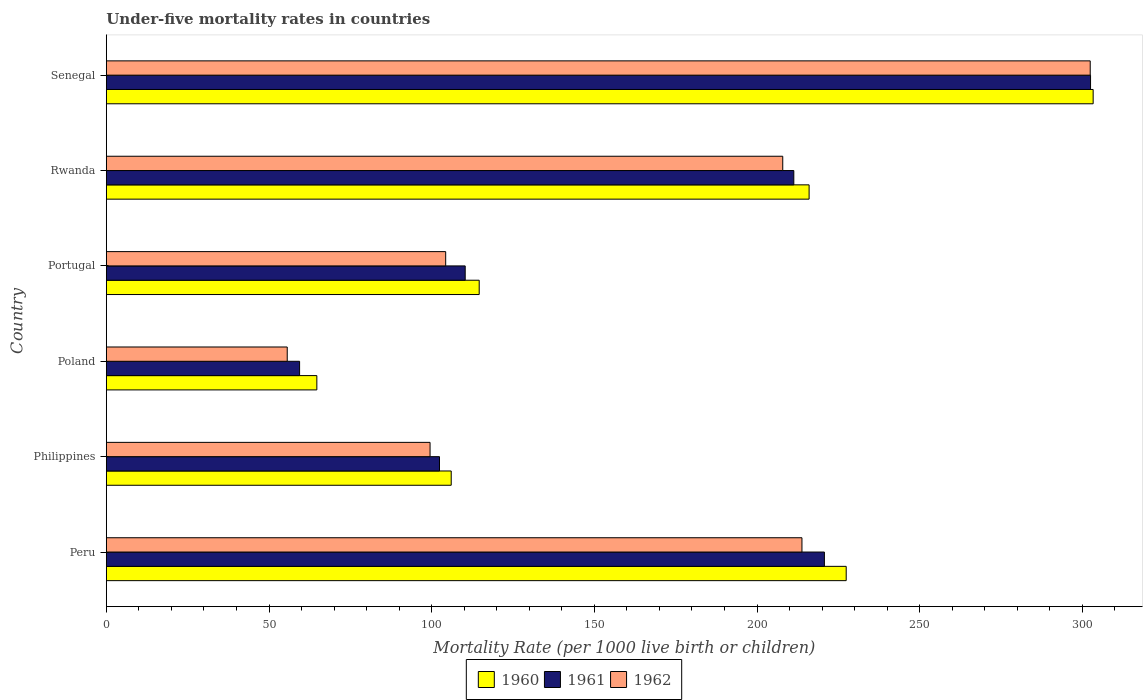How many groups of bars are there?
Offer a very short reply. 6. How many bars are there on the 4th tick from the bottom?
Offer a very short reply. 3. What is the label of the 1st group of bars from the top?
Offer a very short reply. Senegal. In how many cases, is the number of bars for a given country not equal to the number of legend labels?
Provide a succinct answer. 0. What is the under-five mortality rate in 1960 in Portugal?
Provide a short and direct response. 114.6. Across all countries, what is the maximum under-five mortality rate in 1960?
Your answer should be compact. 303.3. Across all countries, what is the minimum under-five mortality rate in 1960?
Offer a terse response. 64.7. In which country was the under-five mortality rate in 1962 maximum?
Ensure brevity in your answer.  Senegal. In which country was the under-five mortality rate in 1960 minimum?
Keep it short and to the point. Poland. What is the total under-five mortality rate in 1960 in the graph?
Offer a very short reply. 1032. What is the difference between the under-five mortality rate in 1961 in Rwanda and that in Senegal?
Offer a terse response. -91.2. What is the difference between the under-five mortality rate in 1961 in Poland and the under-five mortality rate in 1960 in Senegal?
Offer a terse response. -243.9. What is the average under-five mortality rate in 1960 per country?
Your answer should be very brief. 172. What is the difference between the under-five mortality rate in 1962 and under-five mortality rate in 1960 in Rwanda?
Your response must be concise. -8.1. What is the ratio of the under-five mortality rate in 1962 in Philippines to that in Portugal?
Provide a short and direct response. 0.95. Is the difference between the under-five mortality rate in 1962 in Peru and Poland greater than the difference between the under-five mortality rate in 1960 in Peru and Poland?
Keep it short and to the point. No. What is the difference between the highest and the second highest under-five mortality rate in 1960?
Your answer should be very brief. 75.9. What is the difference between the highest and the lowest under-five mortality rate in 1961?
Offer a very short reply. 243.1. Is the sum of the under-five mortality rate in 1960 in Philippines and Rwanda greater than the maximum under-five mortality rate in 1962 across all countries?
Offer a terse response. Yes. What does the 3rd bar from the bottom in Senegal represents?
Ensure brevity in your answer.  1962. How many bars are there?
Your response must be concise. 18. How many countries are there in the graph?
Make the answer very short. 6. How many legend labels are there?
Offer a terse response. 3. How are the legend labels stacked?
Ensure brevity in your answer.  Horizontal. What is the title of the graph?
Provide a short and direct response. Under-five mortality rates in countries. What is the label or title of the X-axis?
Keep it short and to the point. Mortality Rate (per 1000 live birth or children). What is the Mortality Rate (per 1000 live birth or children) in 1960 in Peru?
Ensure brevity in your answer.  227.4. What is the Mortality Rate (per 1000 live birth or children) in 1961 in Peru?
Keep it short and to the point. 220.7. What is the Mortality Rate (per 1000 live birth or children) of 1962 in Peru?
Offer a very short reply. 213.8. What is the Mortality Rate (per 1000 live birth or children) of 1960 in Philippines?
Your response must be concise. 106. What is the Mortality Rate (per 1000 live birth or children) in 1961 in Philippines?
Your answer should be very brief. 102.4. What is the Mortality Rate (per 1000 live birth or children) in 1962 in Philippines?
Make the answer very short. 99.5. What is the Mortality Rate (per 1000 live birth or children) of 1960 in Poland?
Provide a succinct answer. 64.7. What is the Mortality Rate (per 1000 live birth or children) in 1961 in Poland?
Your response must be concise. 59.4. What is the Mortality Rate (per 1000 live birth or children) in 1962 in Poland?
Your answer should be compact. 55.6. What is the Mortality Rate (per 1000 live birth or children) in 1960 in Portugal?
Give a very brief answer. 114.6. What is the Mortality Rate (per 1000 live birth or children) of 1961 in Portugal?
Your response must be concise. 110.3. What is the Mortality Rate (per 1000 live birth or children) of 1962 in Portugal?
Provide a short and direct response. 104.3. What is the Mortality Rate (per 1000 live birth or children) in 1960 in Rwanda?
Your response must be concise. 216. What is the Mortality Rate (per 1000 live birth or children) in 1961 in Rwanda?
Give a very brief answer. 211.3. What is the Mortality Rate (per 1000 live birth or children) in 1962 in Rwanda?
Your response must be concise. 207.9. What is the Mortality Rate (per 1000 live birth or children) in 1960 in Senegal?
Offer a very short reply. 303.3. What is the Mortality Rate (per 1000 live birth or children) of 1961 in Senegal?
Provide a short and direct response. 302.5. What is the Mortality Rate (per 1000 live birth or children) of 1962 in Senegal?
Keep it short and to the point. 302.4. Across all countries, what is the maximum Mortality Rate (per 1000 live birth or children) in 1960?
Keep it short and to the point. 303.3. Across all countries, what is the maximum Mortality Rate (per 1000 live birth or children) of 1961?
Your answer should be compact. 302.5. Across all countries, what is the maximum Mortality Rate (per 1000 live birth or children) in 1962?
Offer a terse response. 302.4. Across all countries, what is the minimum Mortality Rate (per 1000 live birth or children) of 1960?
Give a very brief answer. 64.7. Across all countries, what is the minimum Mortality Rate (per 1000 live birth or children) in 1961?
Keep it short and to the point. 59.4. Across all countries, what is the minimum Mortality Rate (per 1000 live birth or children) in 1962?
Make the answer very short. 55.6. What is the total Mortality Rate (per 1000 live birth or children) of 1960 in the graph?
Offer a terse response. 1032. What is the total Mortality Rate (per 1000 live birth or children) of 1961 in the graph?
Your answer should be compact. 1006.6. What is the total Mortality Rate (per 1000 live birth or children) of 1962 in the graph?
Offer a very short reply. 983.5. What is the difference between the Mortality Rate (per 1000 live birth or children) of 1960 in Peru and that in Philippines?
Offer a very short reply. 121.4. What is the difference between the Mortality Rate (per 1000 live birth or children) of 1961 in Peru and that in Philippines?
Provide a succinct answer. 118.3. What is the difference between the Mortality Rate (per 1000 live birth or children) in 1962 in Peru and that in Philippines?
Offer a terse response. 114.3. What is the difference between the Mortality Rate (per 1000 live birth or children) of 1960 in Peru and that in Poland?
Make the answer very short. 162.7. What is the difference between the Mortality Rate (per 1000 live birth or children) in 1961 in Peru and that in Poland?
Your answer should be compact. 161.3. What is the difference between the Mortality Rate (per 1000 live birth or children) in 1962 in Peru and that in Poland?
Your response must be concise. 158.2. What is the difference between the Mortality Rate (per 1000 live birth or children) of 1960 in Peru and that in Portugal?
Make the answer very short. 112.8. What is the difference between the Mortality Rate (per 1000 live birth or children) in 1961 in Peru and that in Portugal?
Your answer should be very brief. 110.4. What is the difference between the Mortality Rate (per 1000 live birth or children) of 1962 in Peru and that in Portugal?
Provide a succinct answer. 109.5. What is the difference between the Mortality Rate (per 1000 live birth or children) of 1960 in Peru and that in Rwanda?
Provide a succinct answer. 11.4. What is the difference between the Mortality Rate (per 1000 live birth or children) in 1961 in Peru and that in Rwanda?
Offer a very short reply. 9.4. What is the difference between the Mortality Rate (per 1000 live birth or children) of 1960 in Peru and that in Senegal?
Keep it short and to the point. -75.9. What is the difference between the Mortality Rate (per 1000 live birth or children) in 1961 in Peru and that in Senegal?
Offer a very short reply. -81.8. What is the difference between the Mortality Rate (per 1000 live birth or children) in 1962 in Peru and that in Senegal?
Offer a terse response. -88.6. What is the difference between the Mortality Rate (per 1000 live birth or children) in 1960 in Philippines and that in Poland?
Make the answer very short. 41.3. What is the difference between the Mortality Rate (per 1000 live birth or children) of 1961 in Philippines and that in Poland?
Provide a short and direct response. 43. What is the difference between the Mortality Rate (per 1000 live birth or children) in 1962 in Philippines and that in Poland?
Offer a very short reply. 43.9. What is the difference between the Mortality Rate (per 1000 live birth or children) in 1960 in Philippines and that in Portugal?
Your response must be concise. -8.6. What is the difference between the Mortality Rate (per 1000 live birth or children) of 1960 in Philippines and that in Rwanda?
Your answer should be very brief. -110. What is the difference between the Mortality Rate (per 1000 live birth or children) of 1961 in Philippines and that in Rwanda?
Provide a short and direct response. -108.9. What is the difference between the Mortality Rate (per 1000 live birth or children) in 1962 in Philippines and that in Rwanda?
Keep it short and to the point. -108.4. What is the difference between the Mortality Rate (per 1000 live birth or children) in 1960 in Philippines and that in Senegal?
Your answer should be very brief. -197.3. What is the difference between the Mortality Rate (per 1000 live birth or children) in 1961 in Philippines and that in Senegal?
Your answer should be very brief. -200.1. What is the difference between the Mortality Rate (per 1000 live birth or children) in 1962 in Philippines and that in Senegal?
Ensure brevity in your answer.  -202.9. What is the difference between the Mortality Rate (per 1000 live birth or children) in 1960 in Poland and that in Portugal?
Provide a short and direct response. -49.9. What is the difference between the Mortality Rate (per 1000 live birth or children) in 1961 in Poland and that in Portugal?
Ensure brevity in your answer.  -50.9. What is the difference between the Mortality Rate (per 1000 live birth or children) in 1962 in Poland and that in Portugal?
Ensure brevity in your answer.  -48.7. What is the difference between the Mortality Rate (per 1000 live birth or children) of 1960 in Poland and that in Rwanda?
Offer a terse response. -151.3. What is the difference between the Mortality Rate (per 1000 live birth or children) of 1961 in Poland and that in Rwanda?
Provide a succinct answer. -151.9. What is the difference between the Mortality Rate (per 1000 live birth or children) of 1962 in Poland and that in Rwanda?
Your response must be concise. -152.3. What is the difference between the Mortality Rate (per 1000 live birth or children) in 1960 in Poland and that in Senegal?
Make the answer very short. -238.6. What is the difference between the Mortality Rate (per 1000 live birth or children) of 1961 in Poland and that in Senegal?
Make the answer very short. -243.1. What is the difference between the Mortality Rate (per 1000 live birth or children) of 1962 in Poland and that in Senegal?
Provide a succinct answer. -246.8. What is the difference between the Mortality Rate (per 1000 live birth or children) in 1960 in Portugal and that in Rwanda?
Offer a terse response. -101.4. What is the difference between the Mortality Rate (per 1000 live birth or children) in 1961 in Portugal and that in Rwanda?
Make the answer very short. -101. What is the difference between the Mortality Rate (per 1000 live birth or children) of 1962 in Portugal and that in Rwanda?
Provide a succinct answer. -103.6. What is the difference between the Mortality Rate (per 1000 live birth or children) in 1960 in Portugal and that in Senegal?
Ensure brevity in your answer.  -188.7. What is the difference between the Mortality Rate (per 1000 live birth or children) of 1961 in Portugal and that in Senegal?
Your response must be concise. -192.2. What is the difference between the Mortality Rate (per 1000 live birth or children) in 1962 in Portugal and that in Senegal?
Give a very brief answer. -198.1. What is the difference between the Mortality Rate (per 1000 live birth or children) of 1960 in Rwanda and that in Senegal?
Provide a short and direct response. -87.3. What is the difference between the Mortality Rate (per 1000 live birth or children) of 1961 in Rwanda and that in Senegal?
Give a very brief answer. -91.2. What is the difference between the Mortality Rate (per 1000 live birth or children) of 1962 in Rwanda and that in Senegal?
Your answer should be very brief. -94.5. What is the difference between the Mortality Rate (per 1000 live birth or children) of 1960 in Peru and the Mortality Rate (per 1000 live birth or children) of 1961 in Philippines?
Your answer should be compact. 125. What is the difference between the Mortality Rate (per 1000 live birth or children) of 1960 in Peru and the Mortality Rate (per 1000 live birth or children) of 1962 in Philippines?
Offer a terse response. 127.9. What is the difference between the Mortality Rate (per 1000 live birth or children) of 1961 in Peru and the Mortality Rate (per 1000 live birth or children) of 1962 in Philippines?
Offer a very short reply. 121.2. What is the difference between the Mortality Rate (per 1000 live birth or children) of 1960 in Peru and the Mortality Rate (per 1000 live birth or children) of 1961 in Poland?
Your response must be concise. 168. What is the difference between the Mortality Rate (per 1000 live birth or children) in 1960 in Peru and the Mortality Rate (per 1000 live birth or children) in 1962 in Poland?
Offer a terse response. 171.8. What is the difference between the Mortality Rate (per 1000 live birth or children) in 1961 in Peru and the Mortality Rate (per 1000 live birth or children) in 1962 in Poland?
Give a very brief answer. 165.1. What is the difference between the Mortality Rate (per 1000 live birth or children) in 1960 in Peru and the Mortality Rate (per 1000 live birth or children) in 1961 in Portugal?
Offer a very short reply. 117.1. What is the difference between the Mortality Rate (per 1000 live birth or children) of 1960 in Peru and the Mortality Rate (per 1000 live birth or children) of 1962 in Portugal?
Provide a short and direct response. 123.1. What is the difference between the Mortality Rate (per 1000 live birth or children) of 1961 in Peru and the Mortality Rate (per 1000 live birth or children) of 1962 in Portugal?
Ensure brevity in your answer.  116.4. What is the difference between the Mortality Rate (per 1000 live birth or children) of 1960 in Peru and the Mortality Rate (per 1000 live birth or children) of 1962 in Rwanda?
Provide a succinct answer. 19.5. What is the difference between the Mortality Rate (per 1000 live birth or children) in 1961 in Peru and the Mortality Rate (per 1000 live birth or children) in 1962 in Rwanda?
Offer a terse response. 12.8. What is the difference between the Mortality Rate (per 1000 live birth or children) of 1960 in Peru and the Mortality Rate (per 1000 live birth or children) of 1961 in Senegal?
Your response must be concise. -75.1. What is the difference between the Mortality Rate (per 1000 live birth or children) of 1960 in Peru and the Mortality Rate (per 1000 live birth or children) of 1962 in Senegal?
Your answer should be compact. -75. What is the difference between the Mortality Rate (per 1000 live birth or children) of 1961 in Peru and the Mortality Rate (per 1000 live birth or children) of 1962 in Senegal?
Make the answer very short. -81.7. What is the difference between the Mortality Rate (per 1000 live birth or children) in 1960 in Philippines and the Mortality Rate (per 1000 live birth or children) in 1961 in Poland?
Give a very brief answer. 46.6. What is the difference between the Mortality Rate (per 1000 live birth or children) of 1960 in Philippines and the Mortality Rate (per 1000 live birth or children) of 1962 in Poland?
Your response must be concise. 50.4. What is the difference between the Mortality Rate (per 1000 live birth or children) of 1961 in Philippines and the Mortality Rate (per 1000 live birth or children) of 1962 in Poland?
Provide a succinct answer. 46.8. What is the difference between the Mortality Rate (per 1000 live birth or children) of 1960 in Philippines and the Mortality Rate (per 1000 live birth or children) of 1961 in Portugal?
Offer a very short reply. -4.3. What is the difference between the Mortality Rate (per 1000 live birth or children) of 1960 in Philippines and the Mortality Rate (per 1000 live birth or children) of 1962 in Portugal?
Your response must be concise. 1.7. What is the difference between the Mortality Rate (per 1000 live birth or children) of 1961 in Philippines and the Mortality Rate (per 1000 live birth or children) of 1962 in Portugal?
Offer a terse response. -1.9. What is the difference between the Mortality Rate (per 1000 live birth or children) in 1960 in Philippines and the Mortality Rate (per 1000 live birth or children) in 1961 in Rwanda?
Provide a succinct answer. -105.3. What is the difference between the Mortality Rate (per 1000 live birth or children) in 1960 in Philippines and the Mortality Rate (per 1000 live birth or children) in 1962 in Rwanda?
Provide a short and direct response. -101.9. What is the difference between the Mortality Rate (per 1000 live birth or children) in 1961 in Philippines and the Mortality Rate (per 1000 live birth or children) in 1962 in Rwanda?
Offer a terse response. -105.5. What is the difference between the Mortality Rate (per 1000 live birth or children) of 1960 in Philippines and the Mortality Rate (per 1000 live birth or children) of 1961 in Senegal?
Your answer should be very brief. -196.5. What is the difference between the Mortality Rate (per 1000 live birth or children) of 1960 in Philippines and the Mortality Rate (per 1000 live birth or children) of 1962 in Senegal?
Your answer should be compact. -196.4. What is the difference between the Mortality Rate (per 1000 live birth or children) of 1961 in Philippines and the Mortality Rate (per 1000 live birth or children) of 1962 in Senegal?
Provide a short and direct response. -200. What is the difference between the Mortality Rate (per 1000 live birth or children) in 1960 in Poland and the Mortality Rate (per 1000 live birth or children) in 1961 in Portugal?
Provide a succinct answer. -45.6. What is the difference between the Mortality Rate (per 1000 live birth or children) in 1960 in Poland and the Mortality Rate (per 1000 live birth or children) in 1962 in Portugal?
Provide a short and direct response. -39.6. What is the difference between the Mortality Rate (per 1000 live birth or children) of 1961 in Poland and the Mortality Rate (per 1000 live birth or children) of 1962 in Portugal?
Ensure brevity in your answer.  -44.9. What is the difference between the Mortality Rate (per 1000 live birth or children) of 1960 in Poland and the Mortality Rate (per 1000 live birth or children) of 1961 in Rwanda?
Keep it short and to the point. -146.6. What is the difference between the Mortality Rate (per 1000 live birth or children) in 1960 in Poland and the Mortality Rate (per 1000 live birth or children) in 1962 in Rwanda?
Give a very brief answer. -143.2. What is the difference between the Mortality Rate (per 1000 live birth or children) in 1961 in Poland and the Mortality Rate (per 1000 live birth or children) in 1962 in Rwanda?
Provide a short and direct response. -148.5. What is the difference between the Mortality Rate (per 1000 live birth or children) in 1960 in Poland and the Mortality Rate (per 1000 live birth or children) in 1961 in Senegal?
Keep it short and to the point. -237.8. What is the difference between the Mortality Rate (per 1000 live birth or children) in 1960 in Poland and the Mortality Rate (per 1000 live birth or children) in 1962 in Senegal?
Give a very brief answer. -237.7. What is the difference between the Mortality Rate (per 1000 live birth or children) of 1961 in Poland and the Mortality Rate (per 1000 live birth or children) of 1962 in Senegal?
Ensure brevity in your answer.  -243. What is the difference between the Mortality Rate (per 1000 live birth or children) of 1960 in Portugal and the Mortality Rate (per 1000 live birth or children) of 1961 in Rwanda?
Keep it short and to the point. -96.7. What is the difference between the Mortality Rate (per 1000 live birth or children) of 1960 in Portugal and the Mortality Rate (per 1000 live birth or children) of 1962 in Rwanda?
Your response must be concise. -93.3. What is the difference between the Mortality Rate (per 1000 live birth or children) of 1961 in Portugal and the Mortality Rate (per 1000 live birth or children) of 1962 in Rwanda?
Give a very brief answer. -97.6. What is the difference between the Mortality Rate (per 1000 live birth or children) in 1960 in Portugal and the Mortality Rate (per 1000 live birth or children) in 1961 in Senegal?
Your answer should be very brief. -187.9. What is the difference between the Mortality Rate (per 1000 live birth or children) of 1960 in Portugal and the Mortality Rate (per 1000 live birth or children) of 1962 in Senegal?
Your response must be concise. -187.8. What is the difference between the Mortality Rate (per 1000 live birth or children) of 1961 in Portugal and the Mortality Rate (per 1000 live birth or children) of 1962 in Senegal?
Your answer should be compact. -192.1. What is the difference between the Mortality Rate (per 1000 live birth or children) of 1960 in Rwanda and the Mortality Rate (per 1000 live birth or children) of 1961 in Senegal?
Keep it short and to the point. -86.5. What is the difference between the Mortality Rate (per 1000 live birth or children) in 1960 in Rwanda and the Mortality Rate (per 1000 live birth or children) in 1962 in Senegal?
Offer a terse response. -86.4. What is the difference between the Mortality Rate (per 1000 live birth or children) in 1961 in Rwanda and the Mortality Rate (per 1000 live birth or children) in 1962 in Senegal?
Ensure brevity in your answer.  -91.1. What is the average Mortality Rate (per 1000 live birth or children) of 1960 per country?
Offer a terse response. 172. What is the average Mortality Rate (per 1000 live birth or children) of 1961 per country?
Your response must be concise. 167.77. What is the average Mortality Rate (per 1000 live birth or children) of 1962 per country?
Make the answer very short. 163.92. What is the difference between the Mortality Rate (per 1000 live birth or children) of 1960 and Mortality Rate (per 1000 live birth or children) of 1962 in Peru?
Ensure brevity in your answer.  13.6. What is the difference between the Mortality Rate (per 1000 live birth or children) in 1960 and Mortality Rate (per 1000 live birth or children) in 1961 in Philippines?
Provide a succinct answer. 3.6. What is the difference between the Mortality Rate (per 1000 live birth or children) in 1960 and Mortality Rate (per 1000 live birth or children) in 1962 in Philippines?
Offer a very short reply. 6.5. What is the difference between the Mortality Rate (per 1000 live birth or children) in 1960 and Mortality Rate (per 1000 live birth or children) in 1961 in Poland?
Ensure brevity in your answer.  5.3. What is the difference between the Mortality Rate (per 1000 live birth or children) in 1961 and Mortality Rate (per 1000 live birth or children) in 1962 in Poland?
Offer a terse response. 3.8. What is the difference between the Mortality Rate (per 1000 live birth or children) in 1960 and Mortality Rate (per 1000 live birth or children) in 1962 in Portugal?
Ensure brevity in your answer.  10.3. What is the difference between the Mortality Rate (per 1000 live birth or children) in 1960 and Mortality Rate (per 1000 live birth or children) in 1961 in Rwanda?
Your answer should be very brief. 4.7. What is the difference between the Mortality Rate (per 1000 live birth or children) of 1960 and Mortality Rate (per 1000 live birth or children) of 1962 in Rwanda?
Your response must be concise. 8.1. What is the difference between the Mortality Rate (per 1000 live birth or children) in 1961 and Mortality Rate (per 1000 live birth or children) in 1962 in Senegal?
Your response must be concise. 0.1. What is the ratio of the Mortality Rate (per 1000 live birth or children) in 1960 in Peru to that in Philippines?
Keep it short and to the point. 2.15. What is the ratio of the Mortality Rate (per 1000 live birth or children) in 1961 in Peru to that in Philippines?
Your response must be concise. 2.16. What is the ratio of the Mortality Rate (per 1000 live birth or children) in 1962 in Peru to that in Philippines?
Keep it short and to the point. 2.15. What is the ratio of the Mortality Rate (per 1000 live birth or children) of 1960 in Peru to that in Poland?
Make the answer very short. 3.51. What is the ratio of the Mortality Rate (per 1000 live birth or children) of 1961 in Peru to that in Poland?
Give a very brief answer. 3.72. What is the ratio of the Mortality Rate (per 1000 live birth or children) in 1962 in Peru to that in Poland?
Your response must be concise. 3.85. What is the ratio of the Mortality Rate (per 1000 live birth or children) of 1960 in Peru to that in Portugal?
Give a very brief answer. 1.98. What is the ratio of the Mortality Rate (per 1000 live birth or children) of 1961 in Peru to that in Portugal?
Your response must be concise. 2. What is the ratio of the Mortality Rate (per 1000 live birth or children) in 1962 in Peru to that in Portugal?
Keep it short and to the point. 2.05. What is the ratio of the Mortality Rate (per 1000 live birth or children) in 1960 in Peru to that in Rwanda?
Keep it short and to the point. 1.05. What is the ratio of the Mortality Rate (per 1000 live birth or children) of 1961 in Peru to that in Rwanda?
Offer a very short reply. 1.04. What is the ratio of the Mortality Rate (per 1000 live birth or children) in 1962 in Peru to that in Rwanda?
Your answer should be very brief. 1.03. What is the ratio of the Mortality Rate (per 1000 live birth or children) in 1960 in Peru to that in Senegal?
Ensure brevity in your answer.  0.75. What is the ratio of the Mortality Rate (per 1000 live birth or children) of 1961 in Peru to that in Senegal?
Provide a succinct answer. 0.73. What is the ratio of the Mortality Rate (per 1000 live birth or children) in 1962 in Peru to that in Senegal?
Keep it short and to the point. 0.71. What is the ratio of the Mortality Rate (per 1000 live birth or children) in 1960 in Philippines to that in Poland?
Give a very brief answer. 1.64. What is the ratio of the Mortality Rate (per 1000 live birth or children) in 1961 in Philippines to that in Poland?
Ensure brevity in your answer.  1.72. What is the ratio of the Mortality Rate (per 1000 live birth or children) of 1962 in Philippines to that in Poland?
Provide a short and direct response. 1.79. What is the ratio of the Mortality Rate (per 1000 live birth or children) of 1960 in Philippines to that in Portugal?
Your answer should be very brief. 0.93. What is the ratio of the Mortality Rate (per 1000 live birth or children) in 1961 in Philippines to that in Portugal?
Ensure brevity in your answer.  0.93. What is the ratio of the Mortality Rate (per 1000 live birth or children) in 1962 in Philippines to that in Portugal?
Provide a short and direct response. 0.95. What is the ratio of the Mortality Rate (per 1000 live birth or children) in 1960 in Philippines to that in Rwanda?
Your response must be concise. 0.49. What is the ratio of the Mortality Rate (per 1000 live birth or children) in 1961 in Philippines to that in Rwanda?
Your answer should be compact. 0.48. What is the ratio of the Mortality Rate (per 1000 live birth or children) of 1962 in Philippines to that in Rwanda?
Provide a succinct answer. 0.48. What is the ratio of the Mortality Rate (per 1000 live birth or children) in 1960 in Philippines to that in Senegal?
Your answer should be compact. 0.35. What is the ratio of the Mortality Rate (per 1000 live birth or children) of 1961 in Philippines to that in Senegal?
Your answer should be very brief. 0.34. What is the ratio of the Mortality Rate (per 1000 live birth or children) in 1962 in Philippines to that in Senegal?
Provide a succinct answer. 0.33. What is the ratio of the Mortality Rate (per 1000 live birth or children) of 1960 in Poland to that in Portugal?
Your answer should be compact. 0.56. What is the ratio of the Mortality Rate (per 1000 live birth or children) of 1961 in Poland to that in Portugal?
Give a very brief answer. 0.54. What is the ratio of the Mortality Rate (per 1000 live birth or children) in 1962 in Poland to that in Portugal?
Offer a terse response. 0.53. What is the ratio of the Mortality Rate (per 1000 live birth or children) of 1960 in Poland to that in Rwanda?
Provide a succinct answer. 0.3. What is the ratio of the Mortality Rate (per 1000 live birth or children) in 1961 in Poland to that in Rwanda?
Ensure brevity in your answer.  0.28. What is the ratio of the Mortality Rate (per 1000 live birth or children) in 1962 in Poland to that in Rwanda?
Offer a terse response. 0.27. What is the ratio of the Mortality Rate (per 1000 live birth or children) in 1960 in Poland to that in Senegal?
Ensure brevity in your answer.  0.21. What is the ratio of the Mortality Rate (per 1000 live birth or children) in 1961 in Poland to that in Senegal?
Your response must be concise. 0.2. What is the ratio of the Mortality Rate (per 1000 live birth or children) of 1962 in Poland to that in Senegal?
Give a very brief answer. 0.18. What is the ratio of the Mortality Rate (per 1000 live birth or children) in 1960 in Portugal to that in Rwanda?
Your answer should be compact. 0.53. What is the ratio of the Mortality Rate (per 1000 live birth or children) of 1961 in Portugal to that in Rwanda?
Provide a succinct answer. 0.52. What is the ratio of the Mortality Rate (per 1000 live birth or children) in 1962 in Portugal to that in Rwanda?
Provide a short and direct response. 0.5. What is the ratio of the Mortality Rate (per 1000 live birth or children) in 1960 in Portugal to that in Senegal?
Provide a succinct answer. 0.38. What is the ratio of the Mortality Rate (per 1000 live birth or children) of 1961 in Portugal to that in Senegal?
Offer a terse response. 0.36. What is the ratio of the Mortality Rate (per 1000 live birth or children) in 1962 in Portugal to that in Senegal?
Provide a succinct answer. 0.34. What is the ratio of the Mortality Rate (per 1000 live birth or children) of 1960 in Rwanda to that in Senegal?
Ensure brevity in your answer.  0.71. What is the ratio of the Mortality Rate (per 1000 live birth or children) in 1961 in Rwanda to that in Senegal?
Offer a very short reply. 0.7. What is the ratio of the Mortality Rate (per 1000 live birth or children) of 1962 in Rwanda to that in Senegal?
Give a very brief answer. 0.69. What is the difference between the highest and the second highest Mortality Rate (per 1000 live birth or children) in 1960?
Provide a short and direct response. 75.9. What is the difference between the highest and the second highest Mortality Rate (per 1000 live birth or children) in 1961?
Keep it short and to the point. 81.8. What is the difference between the highest and the second highest Mortality Rate (per 1000 live birth or children) in 1962?
Provide a short and direct response. 88.6. What is the difference between the highest and the lowest Mortality Rate (per 1000 live birth or children) of 1960?
Offer a terse response. 238.6. What is the difference between the highest and the lowest Mortality Rate (per 1000 live birth or children) of 1961?
Your answer should be very brief. 243.1. What is the difference between the highest and the lowest Mortality Rate (per 1000 live birth or children) in 1962?
Give a very brief answer. 246.8. 